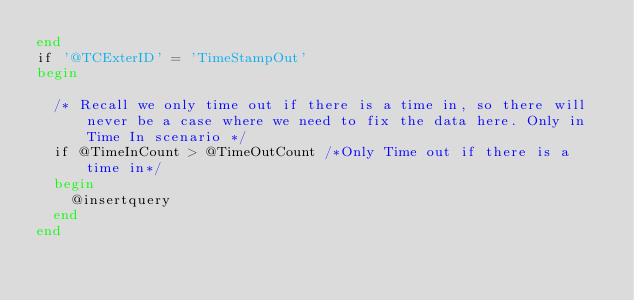Convert code to text. <code><loc_0><loc_0><loc_500><loc_500><_SQL_>end
if '@TCExterID' = 'TimeStampOut'
begin

	/* Recall we only time out if there is a time in, so there will never be a case where we need to fix the data here. Only in Time In scenario */
	if @TimeInCount > @TimeOutCount /*Only Time out if there is a time in*/
	begin 
		@insertquery 
	end
end</code> 